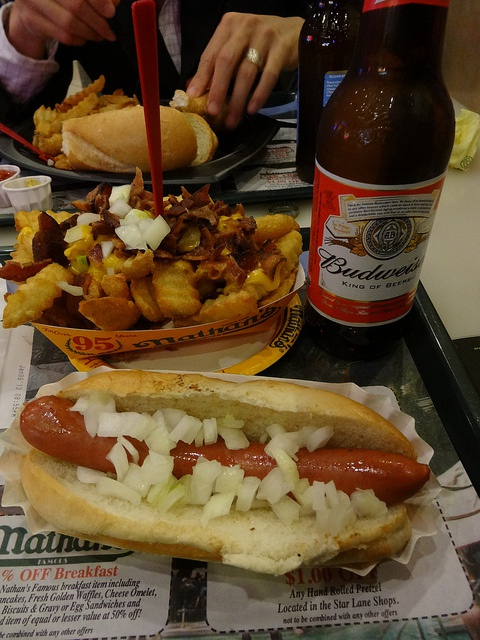Describe the objects in this image and their specific colors. I can see hot dog in black, tan, maroon, and olive tones, bottle in black, gray, and maroon tones, people in black, maroon, and brown tones, bottle in black, navy, gray, and darkgray tones, and cup in black, darkgray, and gray tones in this image. 